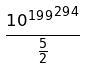<formula> <loc_0><loc_0><loc_500><loc_500>\frac { { 1 0 ^ { 1 9 9 } } ^ { 2 9 4 } } { \frac { 5 } { 2 } }</formula> 